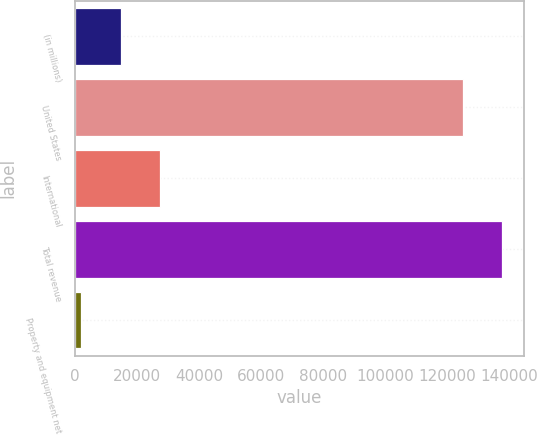<chart> <loc_0><loc_0><loc_500><loc_500><bar_chart><fcel>(in millions)<fcel>United States<fcel>International<fcel>Total revenue<fcel>Property and equipment net<nl><fcel>14688.7<fcel>125006<fcel>27498.4<fcel>137816<fcel>1879<nl></chart> 